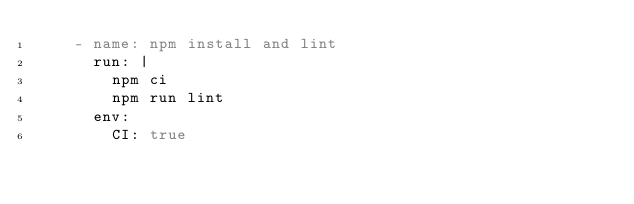<code> <loc_0><loc_0><loc_500><loc_500><_YAML_>    - name: npm install and lint
      run: |
        npm ci
        npm run lint
      env:
        CI: true
</code> 